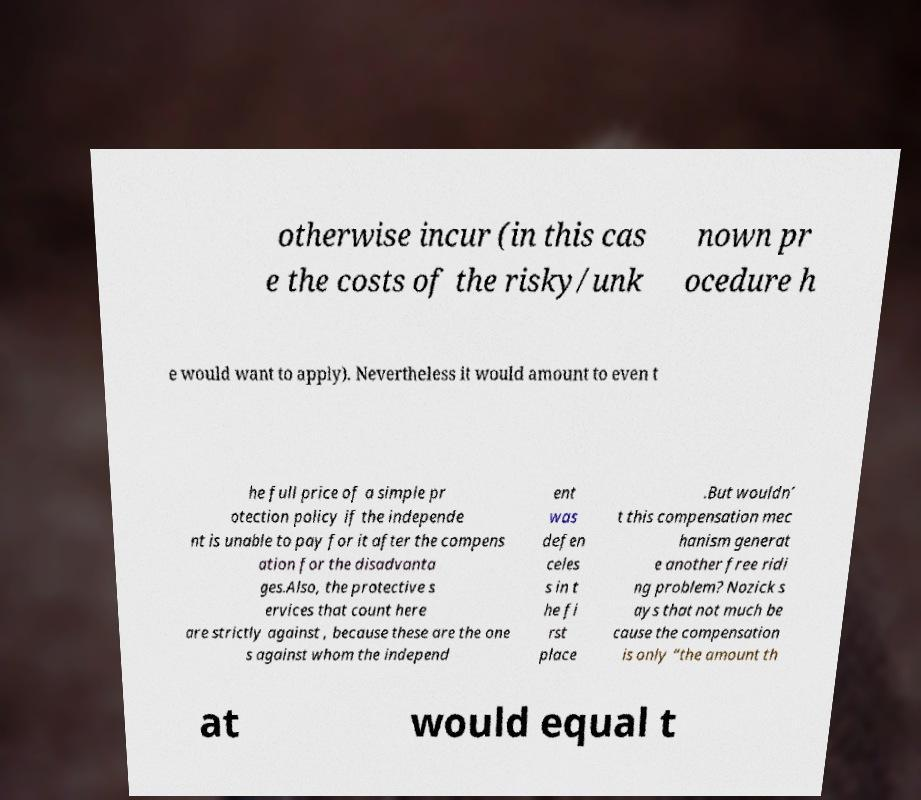Could you extract and type out the text from this image? otherwise incur (in this cas e the costs of the risky/unk nown pr ocedure h e would want to apply). Nevertheless it would amount to even t he full price of a simple pr otection policy if the independe nt is unable to pay for it after the compens ation for the disadvanta ges.Also, the protective s ervices that count here are strictly against , because these are the one s against whom the independ ent was defen celes s in t he fi rst place .But wouldn’ t this compensation mec hanism generat e another free ridi ng problem? Nozick s ays that not much be cause the compensation is only “the amount th at would equal t 